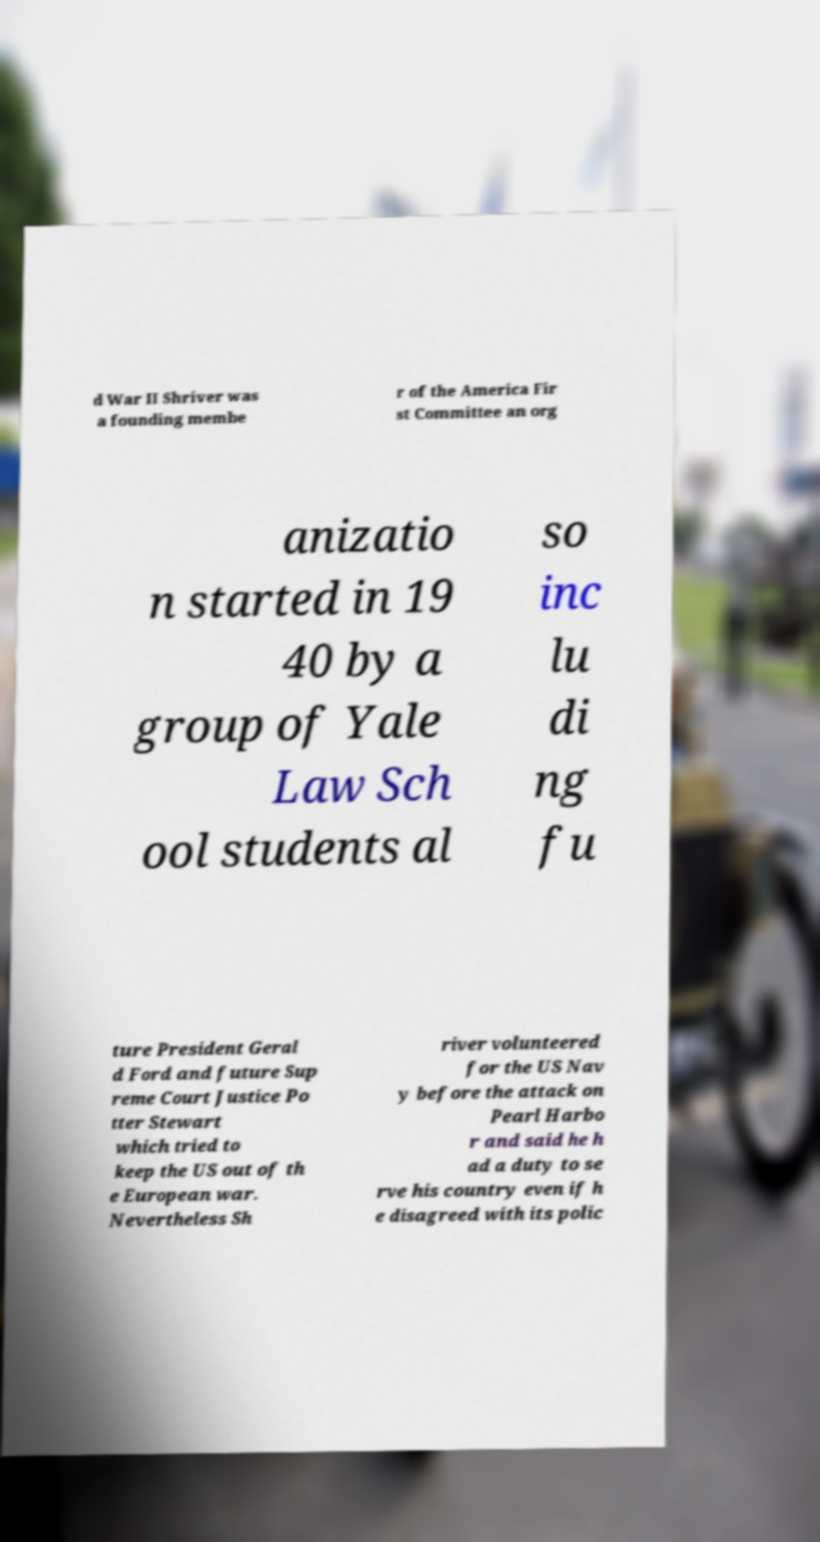Can you read and provide the text displayed in the image?This photo seems to have some interesting text. Can you extract and type it out for me? d War II Shriver was a founding membe r of the America Fir st Committee an org anizatio n started in 19 40 by a group of Yale Law Sch ool students al so inc lu di ng fu ture President Geral d Ford and future Sup reme Court Justice Po tter Stewart which tried to keep the US out of th e European war. Nevertheless Sh river volunteered for the US Nav y before the attack on Pearl Harbo r and said he h ad a duty to se rve his country even if h e disagreed with its polic 